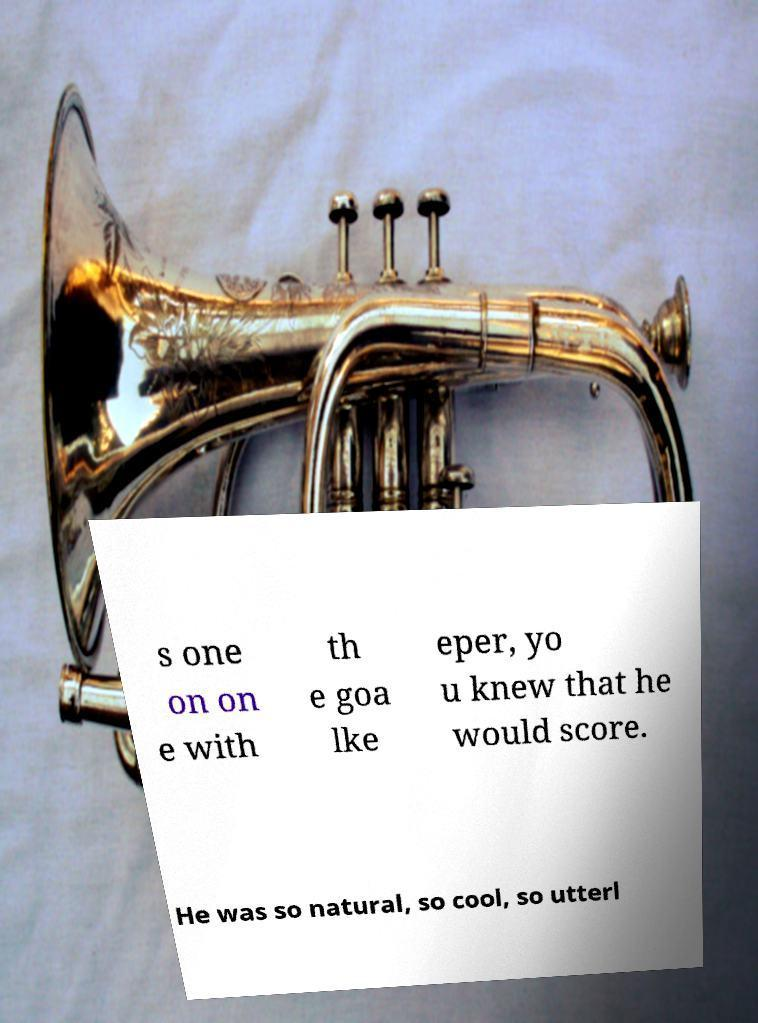I need the written content from this picture converted into text. Can you do that? s one on on e with th e goa lke eper, yo u knew that he would score. He was so natural, so cool, so utterl 